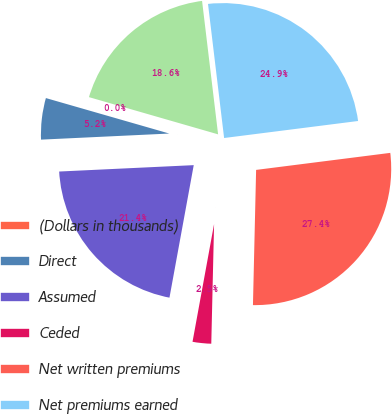Convert chart. <chart><loc_0><loc_0><loc_500><loc_500><pie_chart><fcel>(Dollars in thousands)<fcel>Direct<fcel>Assumed<fcel>Ceded<fcel>Net written premiums<fcel>Net premiums earned<fcel>Net incurred losses and LAE<nl><fcel>0.01%<fcel>5.21%<fcel>21.36%<fcel>2.51%<fcel>27.38%<fcel>24.89%<fcel>18.63%<nl></chart> 